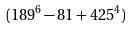<formula> <loc_0><loc_0><loc_500><loc_500>( 1 8 9 ^ { 6 } - 8 1 + 4 2 5 ^ { 4 } )</formula> 